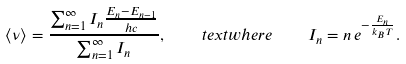Convert formula to latex. <formula><loc_0><loc_0><loc_500><loc_500>\langle \nu \rangle = \frac { \sum _ { n = 1 } ^ { \infty } I _ { n } \frac { E _ { n } - E _ { n - 1 } } { h c } } { \sum _ { n = 1 } ^ { \infty } I _ { n } } , \quad t e x t { w h e r e } \quad I _ { n } = n \, e ^ { - \frac { E _ { n } } { k _ { B } T } } .</formula> 